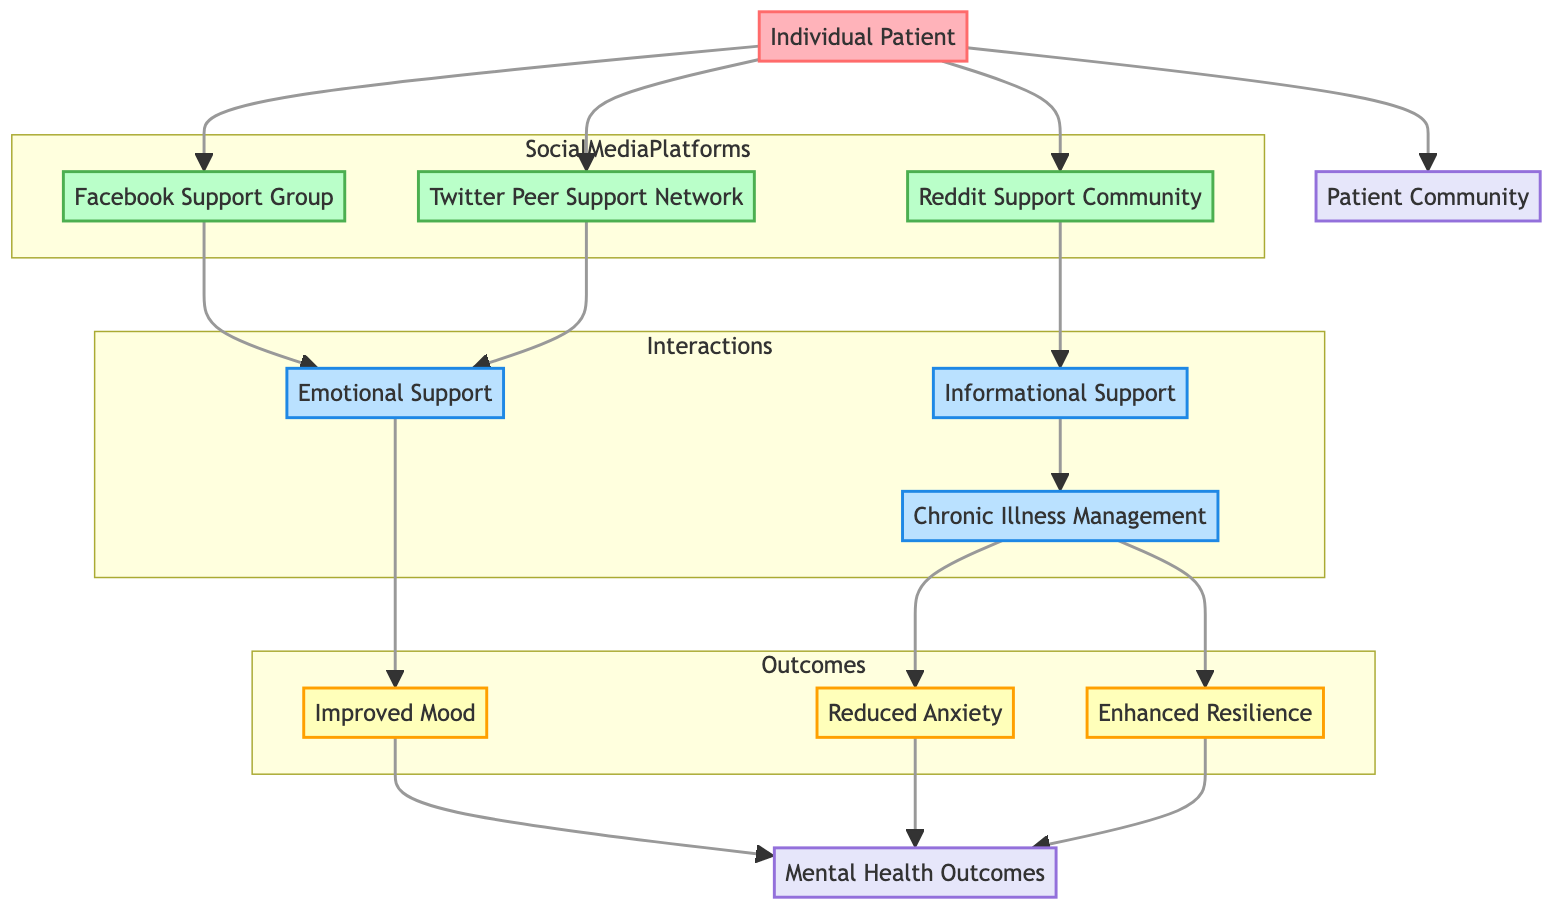What is the total number of nodes in the diagram? The diagram contains one actor (Individual Patient), three platforms (Facebook Support Group, Reddit Support Community, Twitter Peer Support Network), three interactions (Emotional Support, Informational Support, Chronic Illness Management), and three outcomes (Improved Mood, Reduced Anxiety, Enhanced Resilience). Adding these up gives a total of ten nodes: 1 (actor) + 3 (platforms) + 3 (interactions) + 3 (outcomes) = 10.
Answer: 10 Which platform is connected to emotional support? The Facebook Support Group and the Twitter Peer Support Network are both connected to emotional support in the diagram. Examining the edges connected to emotional support reveals that two platforms lead to it.
Answer: Facebook Support Group and Twitter Peer Support Network What type of relationship exists between the individual patient and the patient community? The relationship between the Individual Patient and the Patient Community is categorized as "part of." This is seen from the edge that connects the individual patient directly to the patient community, indicating membership in the larger patient group.
Answer: part of Which interaction leads to reduced anxiety? The interaction that leads to reduced anxiety is Chronic Illness Management. By analyzing the connections, it is traced from Chronic Illness Management to Reduced Anxiety, confirming the pathway.
Answer: Chronic Illness Management How many outcomes are aggregated to mental health outcomes? There are three outcomes aggregated to mental health outcomes: Improved Mood, Reduced Anxiety, and Enhanced Resilience. Each of these outcomes connects to mental health outcomes through aggregation edges, so the count is straightforward.
Answer: 3 Which support group provides informational support? The Reddit Support Community is the support group that provides informational support. It is specifically linked in the diagram to the informational support interaction, establishing its role.
Answer: Reddit Support Community What is the relationship between emotional support and improved mood? The relationship between emotional support and improved mood is classified as an "outcome." The diagram shows that emotional support leads directly to improved mood, indicating that emotional support has a positive effect on mood.
Answer: outcome Which patient community is linked to the individual patient? The patient community linked to the individual patient is the "Patient Community." This relationship is depicted by the edge connecting these two nodes, explicitly showing individual membership in the community.
Answer: Patient Community What two outcomes are linked to chronic illness management? Chronic illness management is linked to two outcomes: Reduced Anxiety and Enhanced Resilience. The diagram shows connections from chronic illness management to both of these outcomes, indicating its contributions to mental health.
Answer: Reduced Anxiety and Enhanced Resilience 